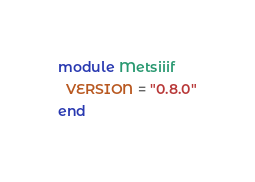Convert code to text. <code><loc_0><loc_0><loc_500><loc_500><_Ruby_>module Metsiiif
  VERSION = "0.8.0"
end
</code> 